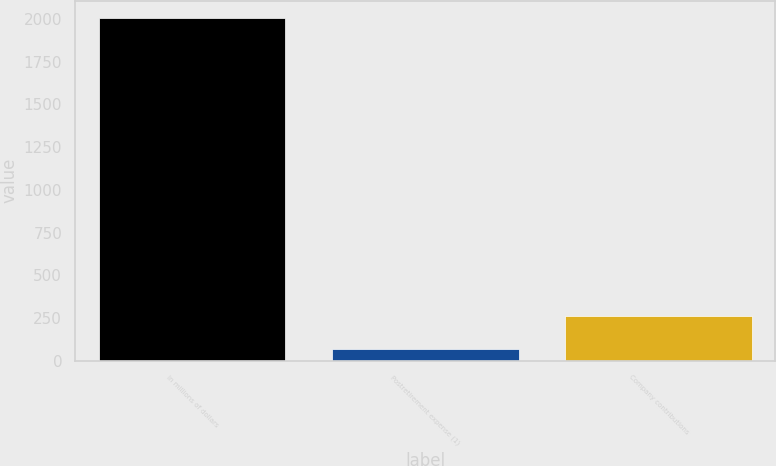Convert chart. <chart><loc_0><loc_0><loc_500><loc_500><bar_chart><fcel>In millions of dollars<fcel>Postretirement expense (1)<fcel>Company contributions<nl><fcel>2006<fcel>71<fcel>264.5<nl></chart> 